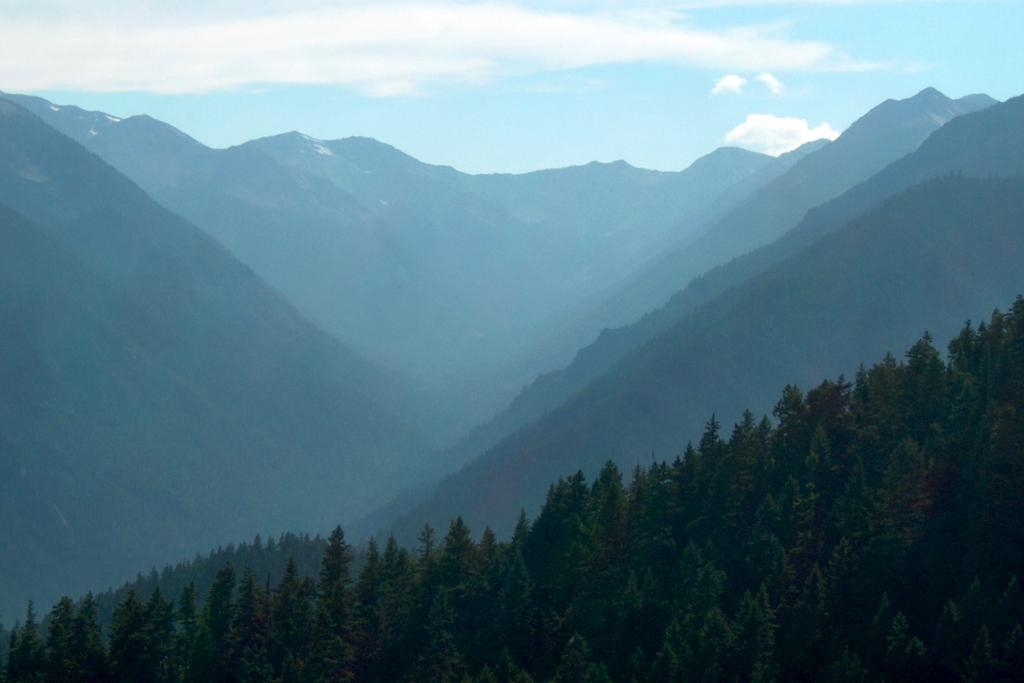What can be seen in the background of the image? The sky and clouds are visible in the background of the image. What type of landform is present in the image? There are hills in the image. What type of vegetation is present at the bottom portion of the image? Trees are present at the bottom portion of the image. Can you see any grapes growing on the trees in the image? There are no grapes present in the image; the trees are not specified as fruit-bearing trees. 